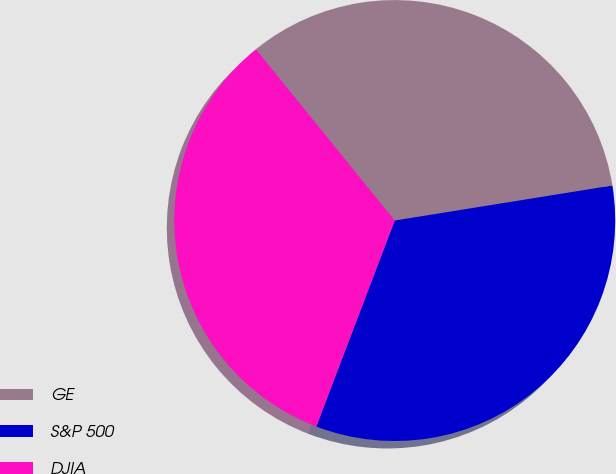Convert chart to OTSL. <chart><loc_0><loc_0><loc_500><loc_500><pie_chart><fcel>GE<fcel>S&P 500<fcel>DJIA<nl><fcel>33.3%<fcel>33.33%<fcel>33.37%<nl></chart> 